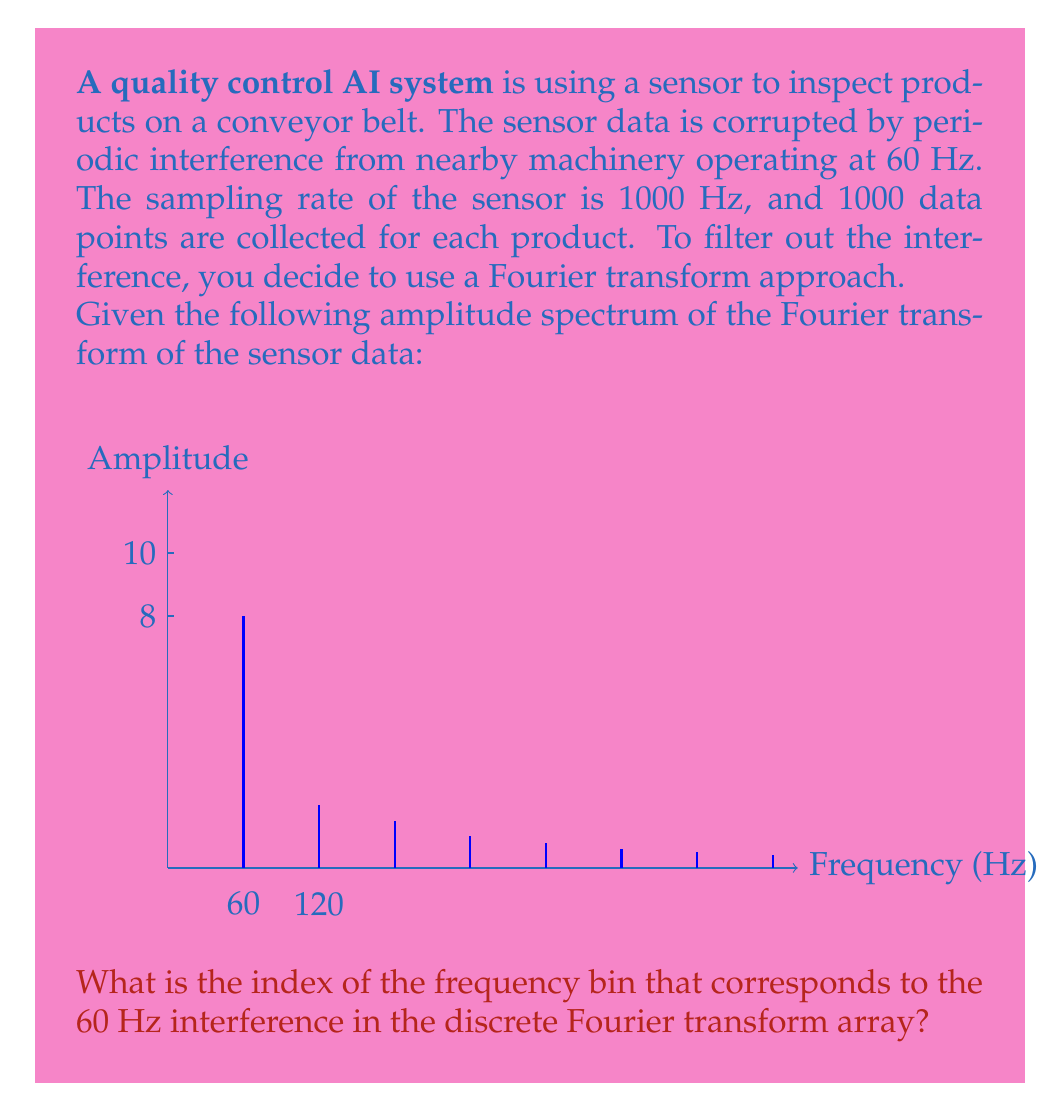What is the answer to this math problem? To solve this problem, we need to understand the relationship between the sampling rate, number of data points, and the frequency resolution in the Fourier transform.

1. First, let's calculate the frequency resolution:
   $$\text{Frequency Resolution} = \frac{\text{Sampling Rate}}{\text{Number of Data Points}} = \frac{1000 \text{ Hz}}{1000} = 1 \text{ Hz}$$

2. This means that each bin in the Fourier transform array represents a 1 Hz increment in frequency.

3. The Fourier transform array indices start at 0, which represents the DC component (0 Hz).

4. To find the index for 60 Hz, we simply need to count the number of bins from 0 Hz to 60 Hz.

5. Since each bin represents 1 Hz, the index for 60 Hz will be 60.

6. However, it's important to note that in most programming languages, array indices start at 0. So the actual index in the array would be 60 - 1 = 59.

Therefore, the 60 Hz interference will appear at index 59 in the discrete Fourier transform array.
Answer: 59 